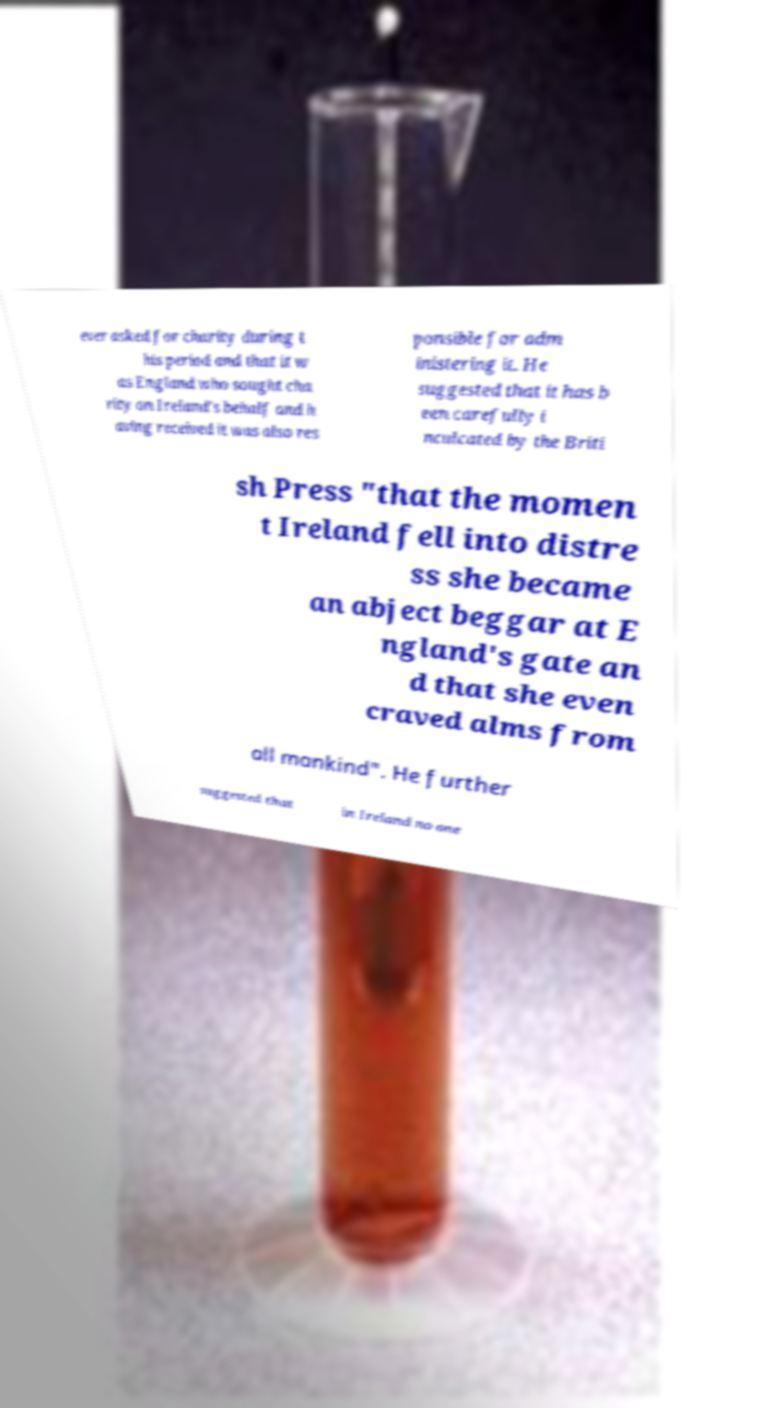What messages or text are displayed in this image? I need them in a readable, typed format. ever asked for charity during t his period and that it w as England who sought cha rity on Ireland's behalf and h aving received it was also res ponsible for adm inistering it. He suggested that it has b een carefully i nculcated by the Briti sh Press "that the momen t Ireland fell into distre ss she became an abject beggar at E ngland's gate an d that she even craved alms from all mankind". He further suggested that in Ireland no one 